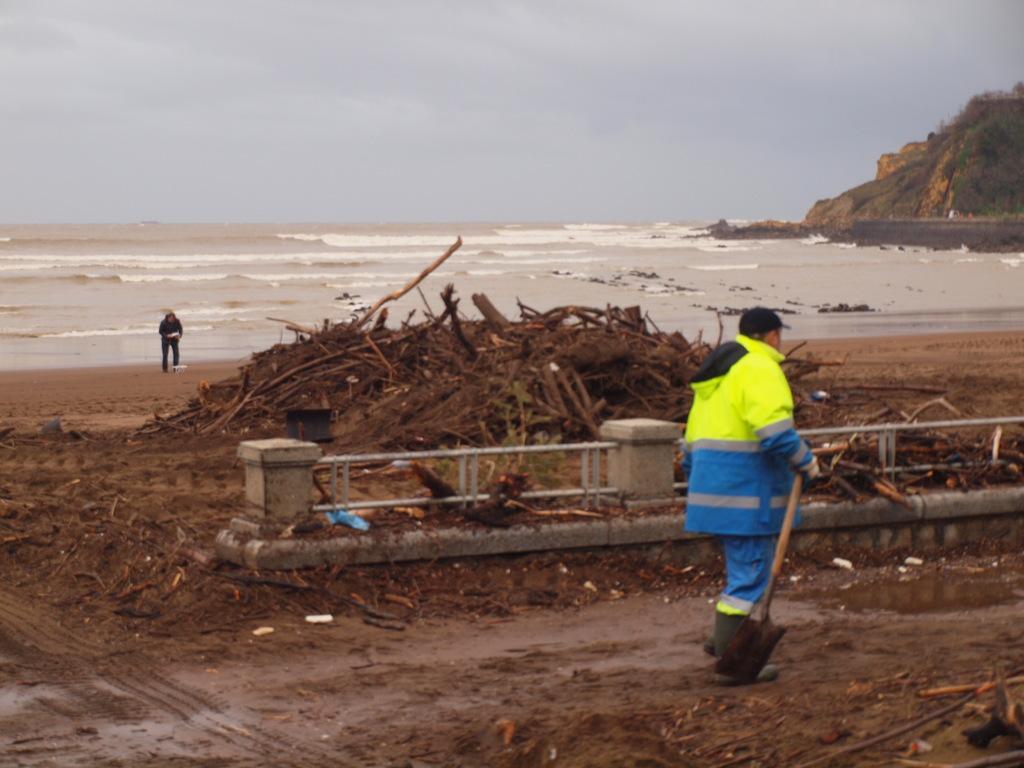How would you summarize this image in a sentence or two? In this image I can see two persons are standing near the beach and are holding objects in hand. In the background I can see wood, water, mountains and the sky. This image is taken may be near the beach. 